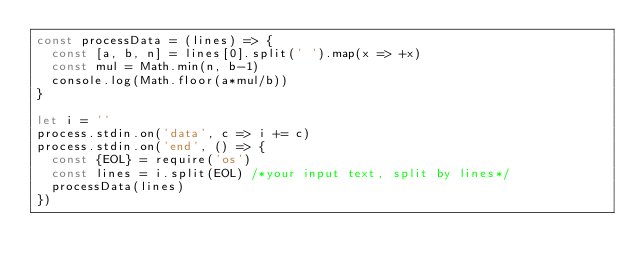Convert code to text. <code><loc_0><loc_0><loc_500><loc_500><_JavaScript_>const processData = (lines) => {
  const [a, b, n] = lines[0].split(' ').map(x => +x)
  const mul = Math.min(n, b-1)
  console.log(Math.floor(a*mul/b))
}

let i = ''
process.stdin.on('data', c => i += c)
process.stdin.on('end', () => {
  const {EOL} = require('os')
  const lines = i.split(EOL) /*your input text, split by lines*/
  processData(lines)
})
</code> 